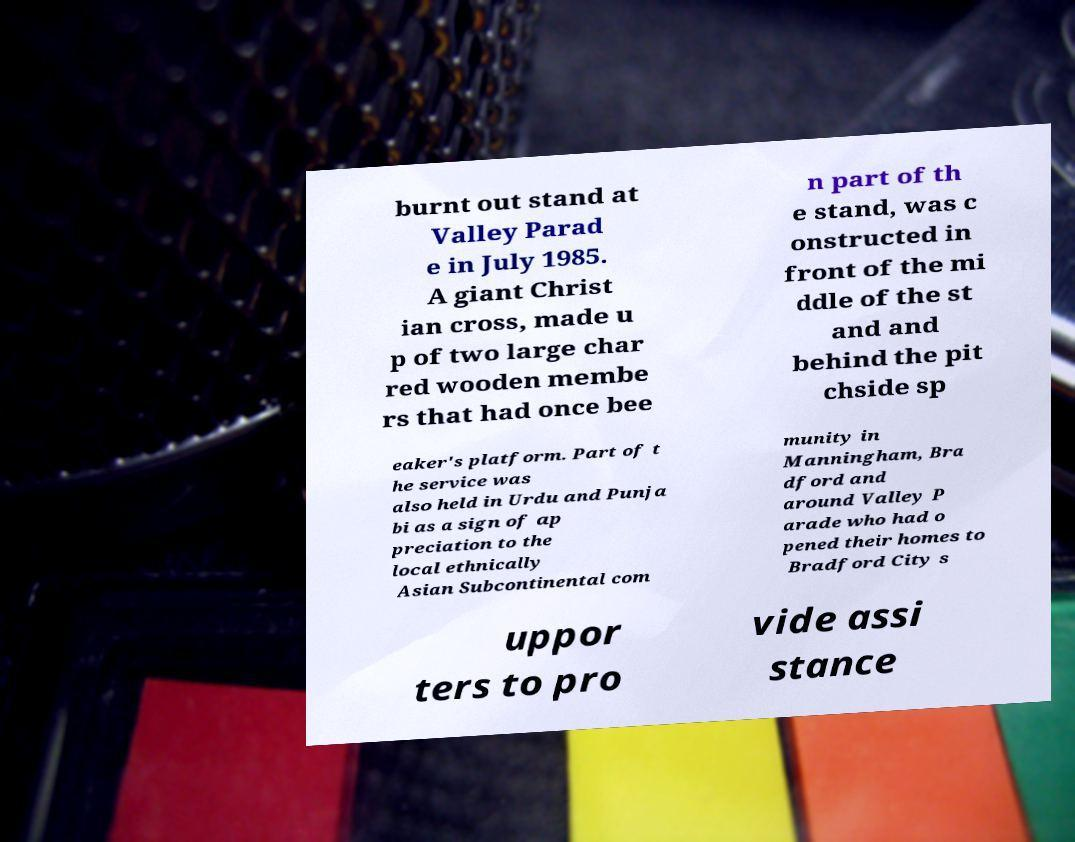Could you assist in decoding the text presented in this image and type it out clearly? burnt out stand at Valley Parad e in July 1985. A giant Christ ian cross, made u p of two large char red wooden membe rs that had once bee n part of th e stand, was c onstructed in front of the mi ddle of the st and and behind the pit chside sp eaker's platform. Part of t he service was also held in Urdu and Punja bi as a sign of ap preciation to the local ethnically Asian Subcontinental com munity in Manningham, Bra dford and around Valley P arade who had o pened their homes to Bradford City s uppor ters to pro vide assi stance 